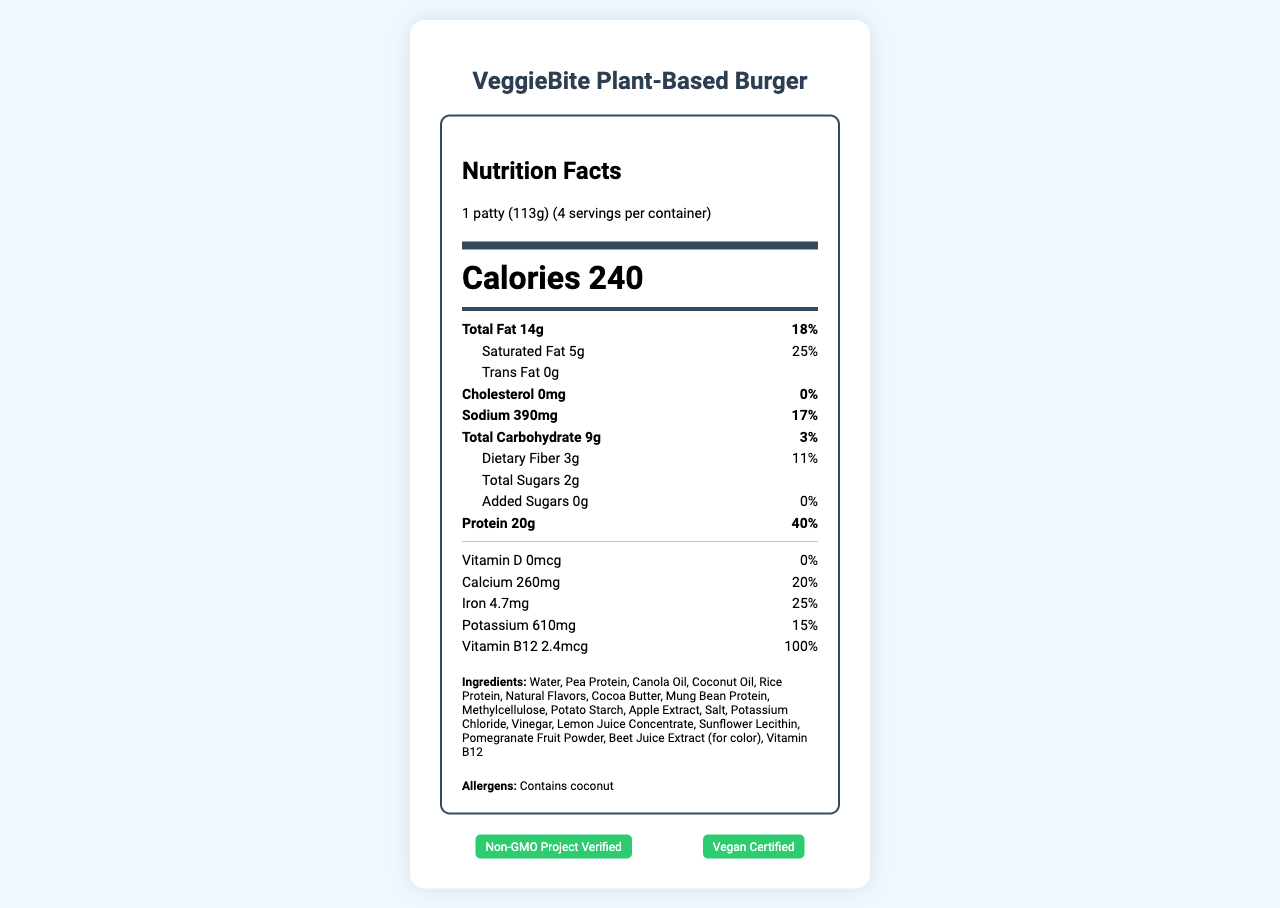what is the serving size of the VeggieBite Plant-Based Burger? The document lists the serving size as "1 patty (113g)" in the serving information section under the nutrition facts header.
Answer: 1 patty (113g) how many calories are there per serving? The document shows the number of calories per serving as "240" in a large, bold font.
Answer: 240 what is the amount of protein per serving? The nutrient section of the document lists protein as "Protein 20g".
Answer: 20g what percentage of the daily value of saturated fat is in one serving? The document indicates "Saturated Fat 5g" and "25%" is stated next to it.
Answer: 25% how much calcium is in one serving? According to the document, the calcium content per serving is "Calcium 260mg".
Answer: 260mg which vitamin is included at 100% of the daily value? The document specifies that Vitamin B12 is present at "2.4mcg" which corresponds to "100% Daily Value".
Answer: Vitamin B12 does the product contain trans fat? The document states "Trans Fat 0g," indicating there is no trans fat in the product.
Answer: No what certifications does the VeggieBite Plant-Based Burger have? The certifications are listed at the bottom of the document as "Non-GMO Project Verified" and "Vegan Certified".
Answer: Non-GMO Project Verified, Vegan Certified what are the main ingredients of the VeggieBite Plant-Based Burger? The main ingredients are listed in the ingredients section of the document, starting with "Water, Pea Protein, Canola Oil, Coconut Oil, Rice Protein".
Answer: Water, Pea Protein, Canola Oil, Coconut Oil, Rice Protein what is the sodium content per serving? The sodium content per serving is stated in the nutrient section as "Sodium 390mg".
Answer: 390mg which ingredient is used for color? A. Beet Juice Extract B. Pomegranate Fruit Powder C. Cocoa Butter The document lists "Beet Juice Extract (for color)" as an ingredient.
Answer: A what is the daily value percentage of iron per serving? A. 15% B. 20% C. 25% D. 40% The daily value percentage for iron is listed as "Iron 4.7mg 25%" in the nutrient section.
Answer: C is this product cholesterol-free? The document states "Cholesterol 0mg" with "0%" daily value, indicating it is cholesterol-free.
Answer: Yes describe the main purpose of this document. The document primarily aims to inform consumers about the nutritional content, ingredients, allergens, certifications, storage, and cooking instructions for the product.
Answer: This document provides the nutrition facts and other relevant details for the VeggieBite Plant-Based Burger. what is the source of protein in the VeggieBite Plant-Based Burger? The document lists multiple sources of protein (e.g., pea protein, rice protein) without specifying a dominant source.
Answer: Cannot be determined 